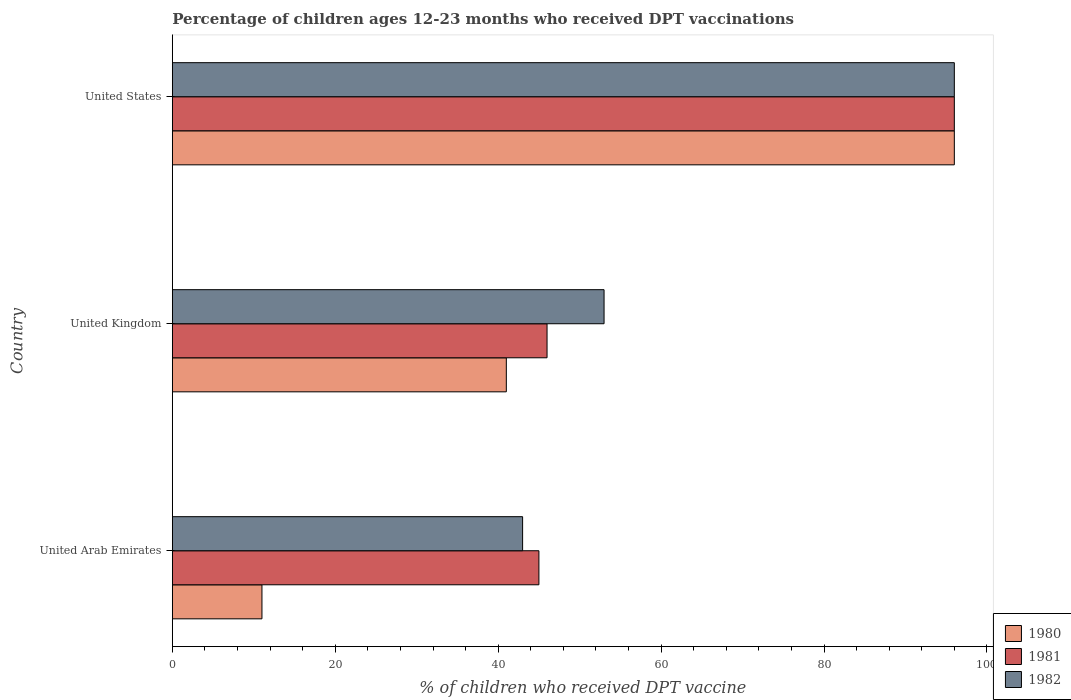How many different coloured bars are there?
Keep it short and to the point. 3. How many groups of bars are there?
Your response must be concise. 3. In how many cases, is the number of bars for a given country not equal to the number of legend labels?
Your answer should be very brief. 0. Across all countries, what is the maximum percentage of children who received DPT vaccination in 1980?
Your response must be concise. 96. In which country was the percentage of children who received DPT vaccination in 1980 maximum?
Provide a succinct answer. United States. In which country was the percentage of children who received DPT vaccination in 1982 minimum?
Your response must be concise. United Arab Emirates. What is the total percentage of children who received DPT vaccination in 1982 in the graph?
Ensure brevity in your answer.  192. What is the difference between the percentage of children who received DPT vaccination in 1982 in United Arab Emirates and that in United States?
Ensure brevity in your answer.  -53. What is the difference between the percentage of children who received DPT vaccination in 1980 in United Kingdom and the percentage of children who received DPT vaccination in 1981 in United Arab Emirates?
Keep it short and to the point. -4. What is the average percentage of children who received DPT vaccination in 1980 per country?
Offer a terse response. 49.33. What is the ratio of the percentage of children who received DPT vaccination in 1981 in United Arab Emirates to that in United Kingdom?
Make the answer very short. 0.98. Is the percentage of children who received DPT vaccination in 1981 in United Arab Emirates less than that in United States?
Your response must be concise. Yes. Is the difference between the percentage of children who received DPT vaccination in 1981 in United Arab Emirates and United Kingdom greater than the difference between the percentage of children who received DPT vaccination in 1980 in United Arab Emirates and United Kingdom?
Offer a very short reply. Yes. In how many countries, is the percentage of children who received DPT vaccination in 1982 greater than the average percentage of children who received DPT vaccination in 1982 taken over all countries?
Ensure brevity in your answer.  1. What does the 2nd bar from the bottom in United States represents?
Your answer should be compact. 1981. Are all the bars in the graph horizontal?
Your answer should be very brief. Yes. How many countries are there in the graph?
Provide a succinct answer. 3. What is the difference between two consecutive major ticks on the X-axis?
Ensure brevity in your answer.  20. Are the values on the major ticks of X-axis written in scientific E-notation?
Give a very brief answer. No. Does the graph contain any zero values?
Give a very brief answer. No. Does the graph contain grids?
Offer a very short reply. No. How many legend labels are there?
Provide a succinct answer. 3. How are the legend labels stacked?
Your answer should be very brief. Vertical. What is the title of the graph?
Your answer should be compact. Percentage of children ages 12-23 months who received DPT vaccinations. What is the label or title of the X-axis?
Offer a very short reply. % of children who received DPT vaccine. What is the label or title of the Y-axis?
Offer a very short reply. Country. What is the % of children who received DPT vaccine of 1980 in United Arab Emirates?
Give a very brief answer. 11. What is the % of children who received DPT vaccine in 1980 in United Kingdom?
Provide a succinct answer. 41. What is the % of children who received DPT vaccine in 1981 in United Kingdom?
Make the answer very short. 46. What is the % of children who received DPT vaccine in 1980 in United States?
Provide a short and direct response. 96. What is the % of children who received DPT vaccine in 1981 in United States?
Keep it short and to the point. 96. What is the % of children who received DPT vaccine in 1982 in United States?
Offer a terse response. 96. Across all countries, what is the maximum % of children who received DPT vaccine of 1980?
Your answer should be compact. 96. Across all countries, what is the maximum % of children who received DPT vaccine of 1981?
Offer a terse response. 96. Across all countries, what is the maximum % of children who received DPT vaccine of 1982?
Your response must be concise. 96. Across all countries, what is the minimum % of children who received DPT vaccine in 1981?
Keep it short and to the point. 45. What is the total % of children who received DPT vaccine in 1980 in the graph?
Ensure brevity in your answer.  148. What is the total % of children who received DPT vaccine of 1981 in the graph?
Your answer should be compact. 187. What is the total % of children who received DPT vaccine in 1982 in the graph?
Give a very brief answer. 192. What is the difference between the % of children who received DPT vaccine in 1980 in United Arab Emirates and that in United Kingdom?
Make the answer very short. -30. What is the difference between the % of children who received DPT vaccine in 1981 in United Arab Emirates and that in United Kingdom?
Provide a succinct answer. -1. What is the difference between the % of children who received DPT vaccine of 1980 in United Arab Emirates and that in United States?
Your answer should be very brief. -85. What is the difference between the % of children who received DPT vaccine in 1981 in United Arab Emirates and that in United States?
Your response must be concise. -51. What is the difference between the % of children who received DPT vaccine in 1982 in United Arab Emirates and that in United States?
Keep it short and to the point. -53. What is the difference between the % of children who received DPT vaccine of 1980 in United Kingdom and that in United States?
Give a very brief answer. -55. What is the difference between the % of children who received DPT vaccine in 1982 in United Kingdom and that in United States?
Keep it short and to the point. -43. What is the difference between the % of children who received DPT vaccine in 1980 in United Arab Emirates and the % of children who received DPT vaccine in 1981 in United Kingdom?
Ensure brevity in your answer.  -35. What is the difference between the % of children who received DPT vaccine of 1980 in United Arab Emirates and the % of children who received DPT vaccine of 1982 in United Kingdom?
Offer a very short reply. -42. What is the difference between the % of children who received DPT vaccine of 1980 in United Arab Emirates and the % of children who received DPT vaccine of 1981 in United States?
Your response must be concise. -85. What is the difference between the % of children who received DPT vaccine of 1980 in United Arab Emirates and the % of children who received DPT vaccine of 1982 in United States?
Provide a short and direct response. -85. What is the difference between the % of children who received DPT vaccine of 1981 in United Arab Emirates and the % of children who received DPT vaccine of 1982 in United States?
Offer a terse response. -51. What is the difference between the % of children who received DPT vaccine of 1980 in United Kingdom and the % of children who received DPT vaccine of 1981 in United States?
Make the answer very short. -55. What is the difference between the % of children who received DPT vaccine in 1980 in United Kingdom and the % of children who received DPT vaccine in 1982 in United States?
Provide a short and direct response. -55. What is the difference between the % of children who received DPT vaccine of 1981 in United Kingdom and the % of children who received DPT vaccine of 1982 in United States?
Provide a short and direct response. -50. What is the average % of children who received DPT vaccine in 1980 per country?
Your response must be concise. 49.33. What is the average % of children who received DPT vaccine in 1981 per country?
Provide a short and direct response. 62.33. What is the average % of children who received DPT vaccine of 1982 per country?
Give a very brief answer. 64. What is the difference between the % of children who received DPT vaccine in 1980 and % of children who received DPT vaccine in 1981 in United Arab Emirates?
Give a very brief answer. -34. What is the difference between the % of children who received DPT vaccine in 1980 and % of children who received DPT vaccine in 1982 in United Arab Emirates?
Your response must be concise. -32. What is the difference between the % of children who received DPT vaccine of 1981 and % of children who received DPT vaccine of 1982 in United Arab Emirates?
Ensure brevity in your answer.  2. What is the difference between the % of children who received DPT vaccine of 1980 and % of children who received DPT vaccine of 1982 in United Kingdom?
Give a very brief answer. -12. What is the difference between the % of children who received DPT vaccine in 1980 and % of children who received DPT vaccine in 1981 in United States?
Offer a very short reply. 0. What is the difference between the % of children who received DPT vaccine of 1980 and % of children who received DPT vaccine of 1982 in United States?
Provide a succinct answer. 0. What is the difference between the % of children who received DPT vaccine of 1981 and % of children who received DPT vaccine of 1982 in United States?
Your answer should be very brief. 0. What is the ratio of the % of children who received DPT vaccine in 1980 in United Arab Emirates to that in United Kingdom?
Offer a terse response. 0.27. What is the ratio of the % of children who received DPT vaccine of 1981 in United Arab Emirates to that in United Kingdom?
Provide a succinct answer. 0.98. What is the ratio of the % of children who received DPT vaccine of 1982 in United Arab Emirates to that in United Kingdom?
Ensure brevity in your answer.  0.81. What is the ratio of the % of children who received DPT vaccine of 1980 in United Arab Emirates to that in United States?
Your response must be concise. 0.11. What is the ratio of the % of children who received DPT vaccine in 1981 in United Arab Emirates to that in United States?
Provide a short and direct response. 0.47. What is the ratio of the % of children who received DPT vaccine of 1982 in United Arab Emirates to that in United States?
Give a very brief answer. 0.45. What is the ratio of the % of children who received DPT vaccine of 1980 in United Kingdom to that in United States?
Offer a terse response. 0.43. What is the ratio of the % of children who received DPT vaccine of 1981 in United Kingdom to that in United States?
Keep it short and to the point. 0.48. What is the ratio of the % of children who received DPT vaccine in 1982 in United Kingdom to that in United States?
Give a very brief answer. 0.55. What is the difference between the highest and the second highest % of children who received DPT vaccine of 1980?
Keep it short and to the point. 55. What is the difference between the highest and the second highest % of children who received DPT vaccine of 1981?
Your answer should be very brief. 50. What is the difference between the highest and the lowest % of children who received DPT vaccine in 1981?
Ensure brevity in your answer.  51. 